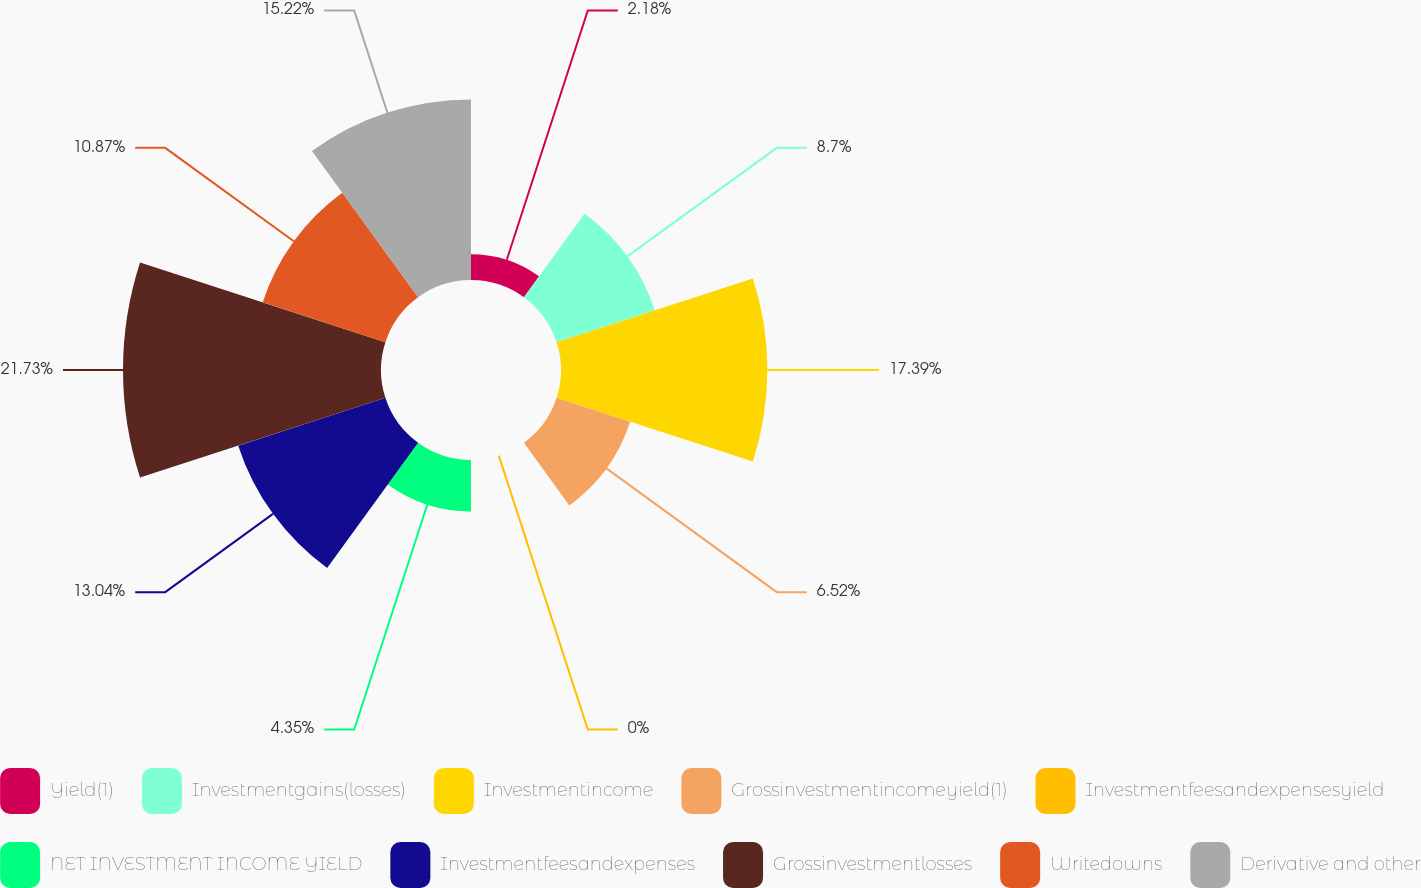Convert chart. <chart><loc_0><loc_0><loc_500><loc_500><pie_chart><fcel>Yield(1)<fcel>Investmentgains(losses)<fcel>Investmentincome<fcel>Grossinvestmentincomeyield(1)<fcel>Investmentfeesandexpensesyield<fcel>NET INVESTMENT INCOME YIELD<fcel>Investmentfeesandexpenses<fcel>Grossinvestmentlosses<fcel>Writedowns<fcel>Derivative and other<nl><fcel>2.18%<fcel>8.7%<fcel>17.39%<fcel>6.52%<fcel>0.0%<fcel>4.35%<fcel>13.04%<fcel>21.74%<fcel>10.87%<fcel>15.22%<nl></chart> 